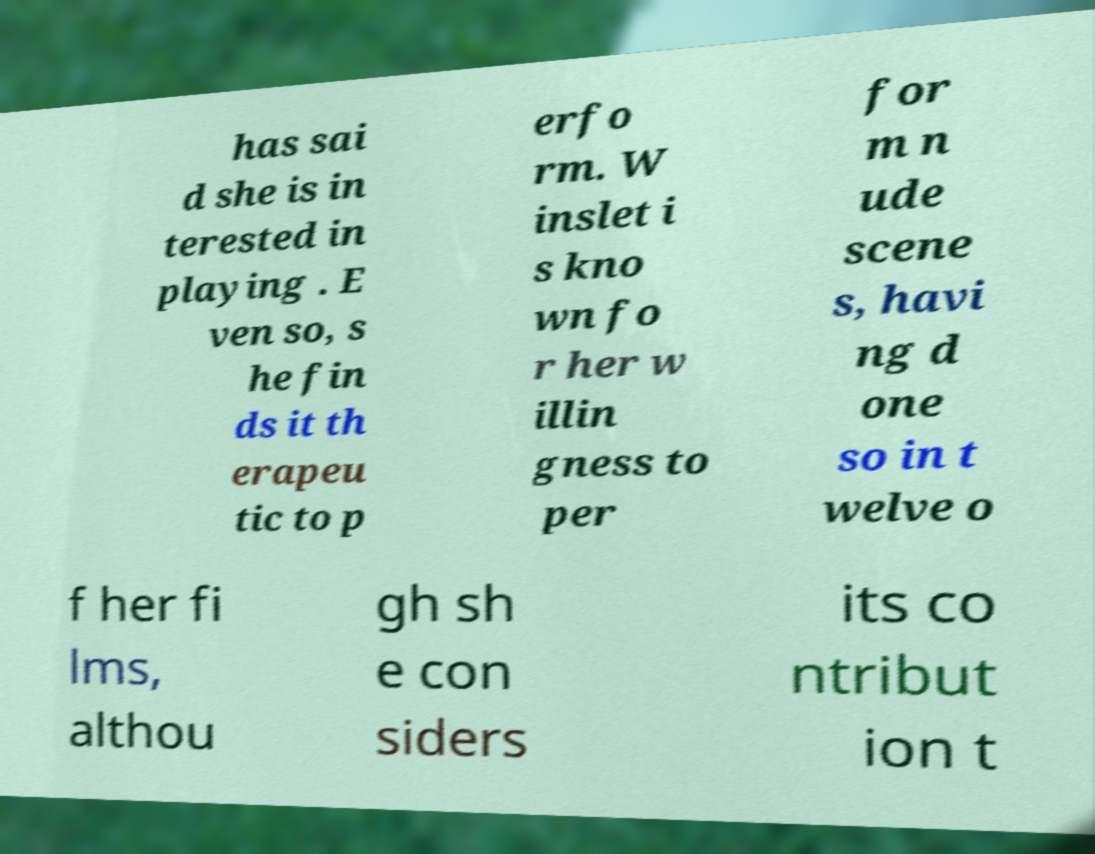Could you extract and type out the text from this image? has sai d she is in terested in playing . E ven so, s he fin ds it th erapeu tic to p erfo rm. W inslet i s kno wn fo r her w illin gness to per for m n ude scene s, havi ng d one so in t welve o f her fi lms, althou gh sh e con siders its co ntribut ion t 